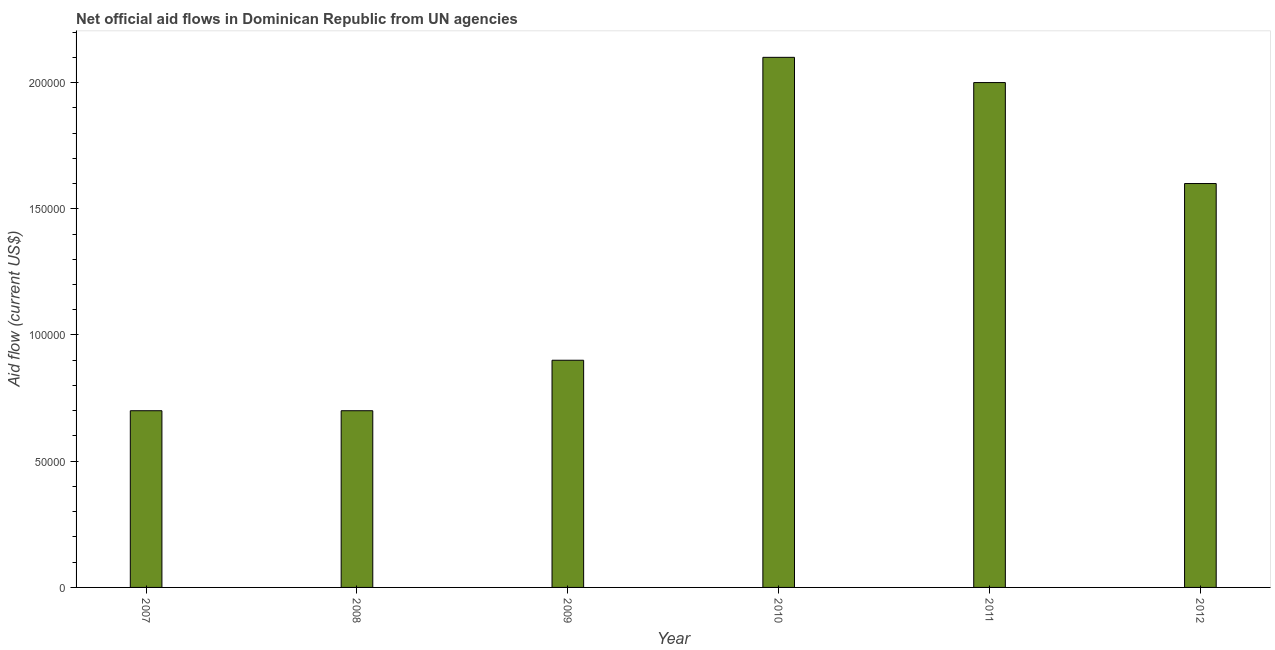Does the graph contain grids?
Your answer should be compact. No. What is the title of the graph?
Keep it short and to the point. Net official aid flows in Dominican Republic from UN agencies. What is the label or title of the X-axis?
Ensure brevity in your answer.  Year. What is the net official flows from un agencies in 2012?
Offer a terse response. 1.60e+05. Across all years, what is the maximum net official flows from un agencies?
Offer a terse response. 2.10e+05. Across all years, what is the minimum net official flows from un agencies?
Keep it short and to the point. 7.00e+04. In which year was the net official flows from un agencies maximum?
Your answer should be very brief. 2010. What is the difference between the net official flows from un agencies in 2008 and 2010?
Keep it short and to the point. -1.40e+05. What is the average net official flows from un agencies per year?
Ensure brevity in your answer.  1.33e+05. What is the median net official flows from un agencies?
Give a very brief answer. 1.25e+05. In how many years, is the net official flows from un agencies greater than 160000 US$?
Your response must be concise. 2. Do a majority of the years between 2009 and 2007 (inclusive) have net official flows from un agencies greater than 150000 US$?
Provide a succinct answer. Yes. What is the ratio of the net official flows from un agencies in 2007 to that in 2009?
Make the answer very short. 0.78. Is the net official flows from un agencies in 2007 less than that in 2008?
Give a very brief answer. No. Is the difference between the net official flows from un agencies in 2010 and 2012 greater than the difference between any two years?
Make the answer very short. No. What is the difference between the highest and the second highest net official flows from un agencies?
Give a very brief answer. 10000. Is the sum of the net official flows from un agencies in 2009 and 2011 greater than the maximum net official flows from un agencies across all years?
Your answer should be very brief. Yes. What is the difference between the highest and the lowest net official flows from un agencies?
Offer a very short reply. 1.40e+05. In how many years, is the net official flows from un agencies greater than the average net official flows from un agencies taken over all years?
Make the answer very short. 3. Are all the bars in the graph horizontal?
Give a very brief answer. No. What is the difference between two consecutive major ticks on the Y-axis?
Make the answer very short. 5.00e+04. Are the values on the major ticks of Y-axis written in scientific E-notation?
Offer a terse response. No. What is the Aid flow (current US$) in 2007?
Offer a very short reply. 7.00e+04. What is the Aid flow (current US$) of 2010?
Provide a short and direct response. 2.10e+05. What is the Aid flow (current US$) of 2011?
Your answer should be very brief. 2.00e+05. What is the Aid flow (current US$) in 2012?
Offer a very short reply. 1.60e+05. What is the difference between the Aid flow (current US$) in 2007 and 2010?
Keep it short and to the point. -1.40e+05. What is the difference between the Aid flow (current US$) in 2007 and 2012?
Your response must be concise. -9.00e+04. What is the difference between the Aid flow (current US$) in 2009 and 2012?
Your response must be concise. -7.00e+04. What is the difference between the Aid flow (current US$) in 2010 and 2012?
Offer a terse response. 5.00e+04. What is the difference between the Aid flow (current US$) in 2011 and 2012?
Offer a terse response. 4.00e+04. What is the ratio of the Aid flow (current US$) in 2007 to that in 2008?
Your answer should be compact. 1. What is the ratio of the Aid flow (current US$) in 2007 to that in 2009?
Make the answer very short. 0.78. What is the ratio of the Aid flow (current US$) in 2007 to that in 2010?
Make the answer very short. 0.33. What is the ratio of the Aid flow (current US$) in 2007 to that in 2012?
Provide a short and direct response. 0.44. What is the ratio of the Aid flow (current US$) in 2008 to that in 2009?
Your answer should be very brief. 0.78. What is the ratio of the Aid flow (current US$) in 2008 to that in 2010?
Your answer should be very brief. 0.33. What is the ratio of the Aid flow (current US$) in 2008 to that in 2011?
Your answer should be compact. 0.35. What is the ratio of the Aid flow (current US$) in 2008 to that in 2012?
Make the answer very short. 0.44. What is the ratio of the Aid flow (current US$) in 2009 to that in 2010?
Offer a terse response. 0.43. What is the ratio of the Aid flow (current US$) in 2009 to that in 2011?
Provide a succinct answer. 0.45. What is the ratio of the Aid flow (current US$) in 2009 to that in 2012?
Keep it short and to the point. 0.56. What is the ratio of the Aid flow (current US$) in 2010 to that in 2012?
Your answer should be compact. 1.31. 